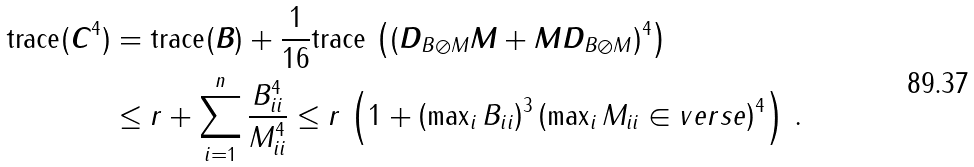<formula> <loc_0><loc_0><loc_500><loc_500>\text {trace} ( \boldsymbol C ^ { 4 } ) & = \text {trace} ( \boldsymbol B ) + \frac { 1 } { 1 6 } \text {trace} \, \left ( ( \boldsymbol D _ { B \oslash M } \boldsymbol M + \boldsymbol M \boldsymbol D _ { B \oslash M } ) ^ { 4 } \right ) \, \\ & \leq r + \sum _ { i = 1 } ^ { n } \frac { B _ { i i } ^ { 4 } } { M _ { i i } ^ { 4 } } \leq r \, \left ( 1 + \left ( \max \nolimits _ { i } B _ { i i } \right ) ^ { 3 } \left ( \max \nolimits _ { i } M _ { i i } \in v e r s e \right ) ^ { 4 } \right ) \, .</formula> 